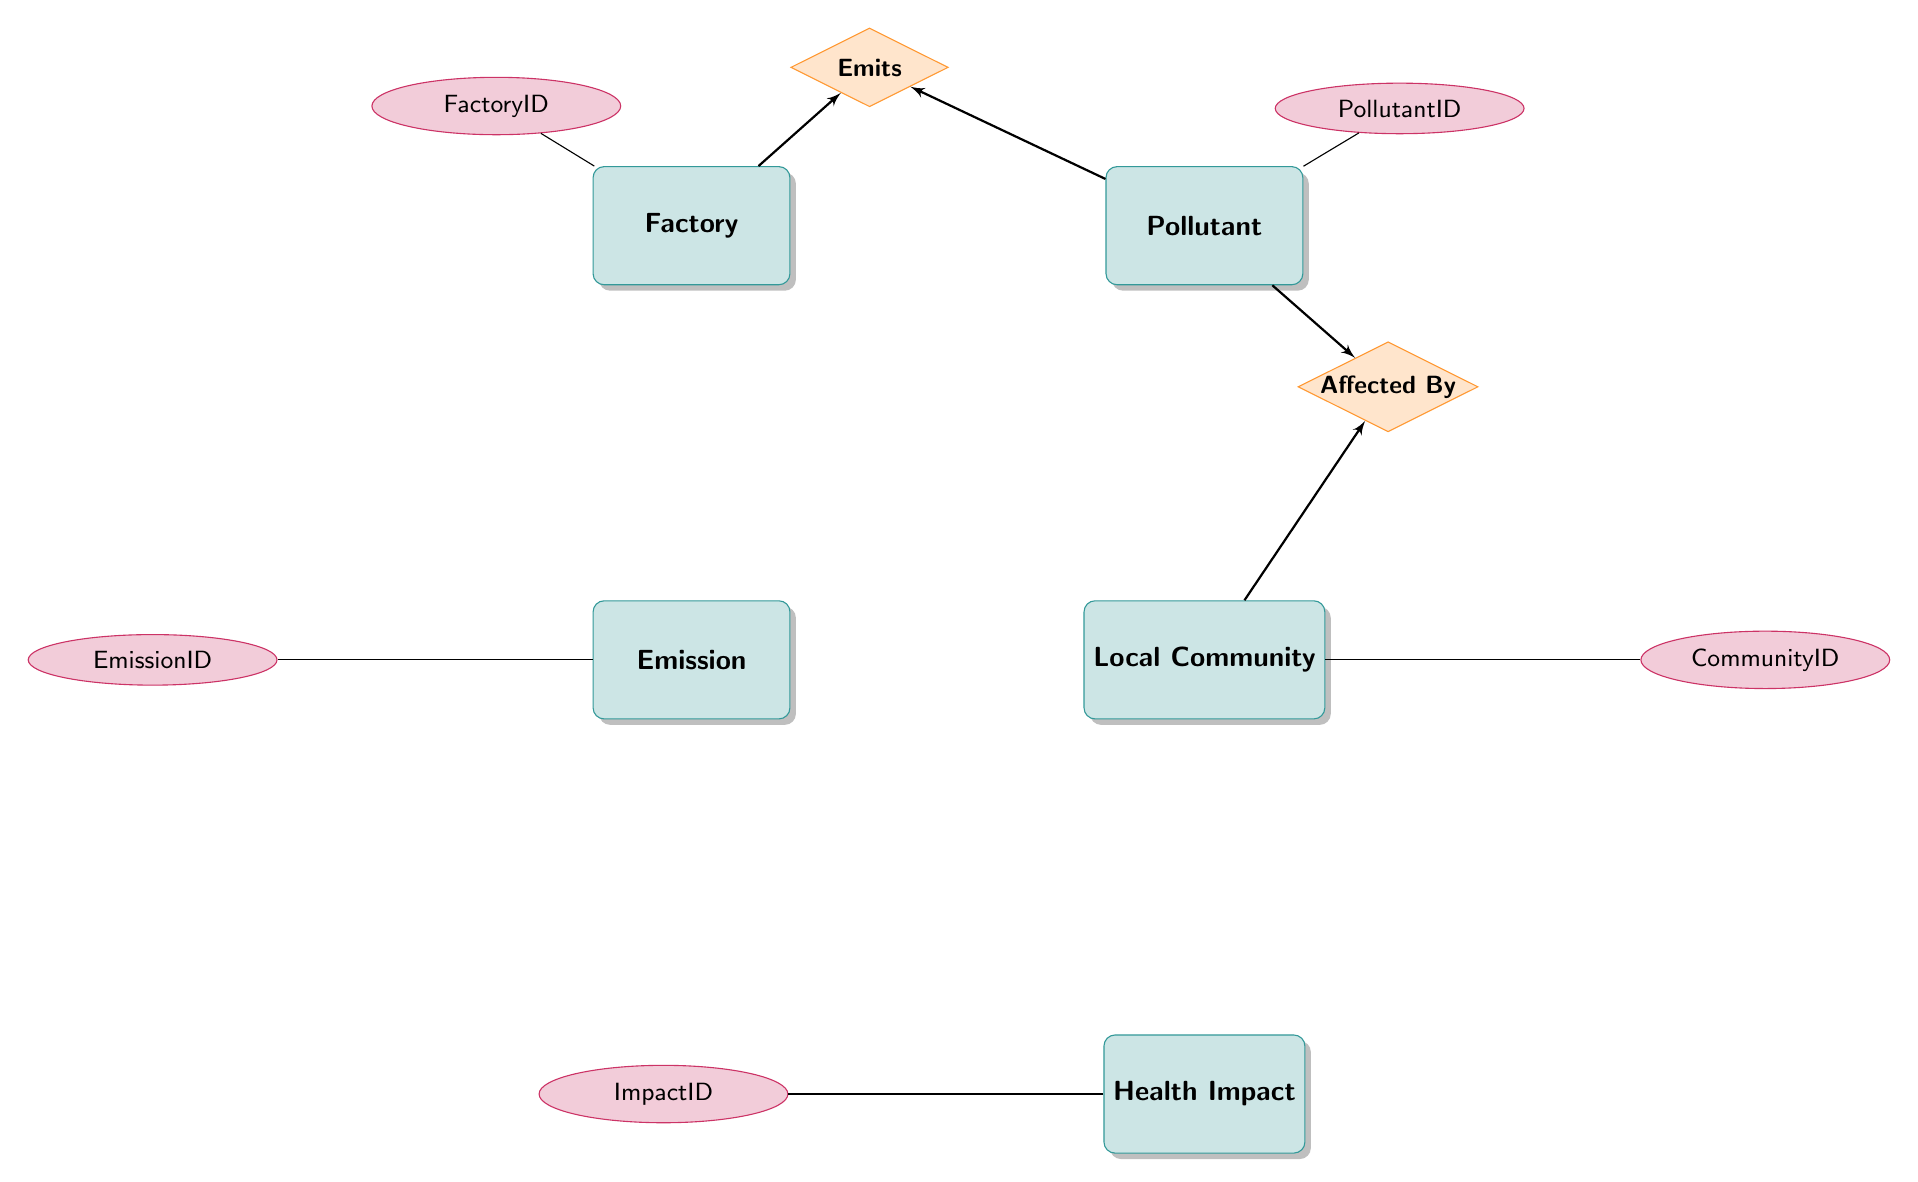What does the "Emits" relationship represent? The "Emits" relationship illustrates how a factory releases certain pollutants into the environment. It connects the Factory entity to the Pollutant entity, indicating that specific pollutants are emitted by the factory.
Answer: emits How many main entities are in the diagram? The diagram contains five main entities: Factory, Pollutant, Emission, Local Community, and Health Impact. Counting these gives a total of five distinct entities.
Answer: 5 Which entity is linked to "Health Impact"? The "Health Impact" entity is connected to the "Local Community" entity through the "Affected By" relationship, which shows that communities can experience health impacts due to pollution.
Answer: Local Community What is the primary key attribute of the "Pollutant" entity? In the diagram, the primary key attribute for the "Pollutant" entity is the "PollutantID", which uniquely identifies each pollutant within the context of this model.
Answer: PollutantID Which entities are involved in the "Affected By" relationship? The "Affected By" relationship takes place between the entities "Local Community" and "Pollutant." It shows that communities are impacted by pollutants, which can lead to health concerns.
Answer: Local Community, Pollutant How many relationships are depicted in the diagram? The diagram depicts two relationships: "Emits" and "Affected By." Each relationship connects specific entities, demonstrating how they interact within the environmental impact context.
Answer: 2 What attribute links "Emission" to "Factory"? The "Emission" entity features the attribute "FactoryID," which serves as a foreign key linking emissions to the specific factory that produced them.
Answer: FactoryID What type of data does the "HealthImpact" entity record? The "HealthImpact" entity records data regarding the number of reported health cases associated with pollutants impacting specific communities, as shown by the "ReportedCases" attribute.
Answer: ReportedCases What does "EnvironmentalEffect" describe in the context of pollutants? The "EnvironmentalEffect" attribute in the "Pollutant" entity describes the negative impacts that specific pollutants can have on the environment, which is vital for understanding their influence.
Answer: EnvironmentalEffect 